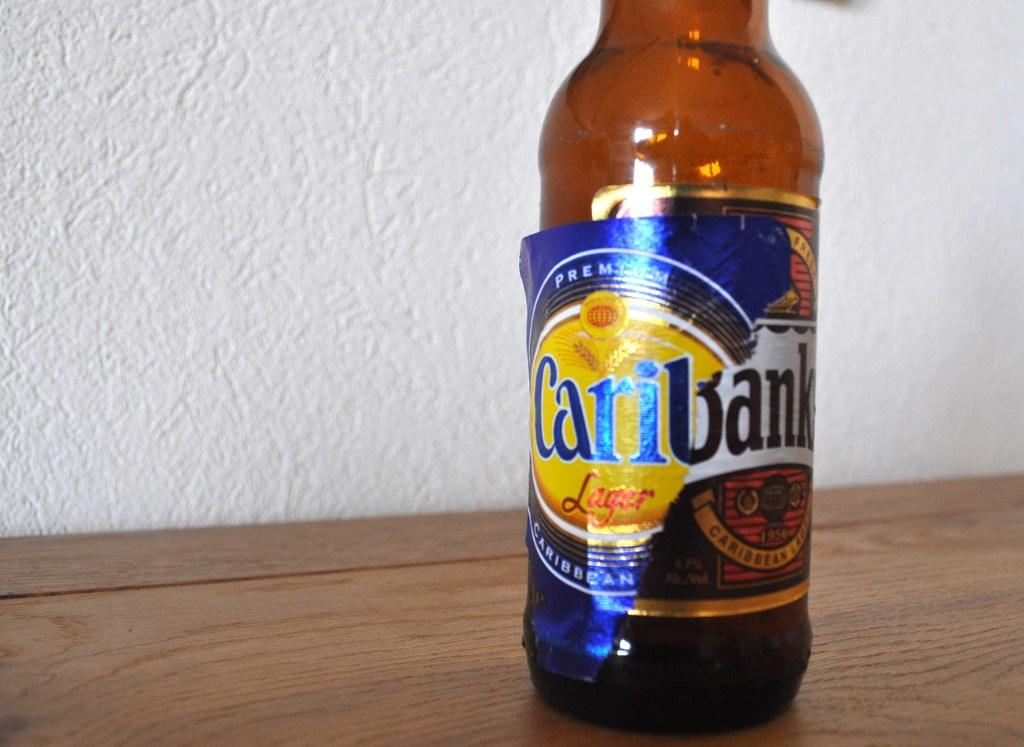<image>
Present a compact description of the photo's key features. Bottle of Caribank beer with a blue label. 